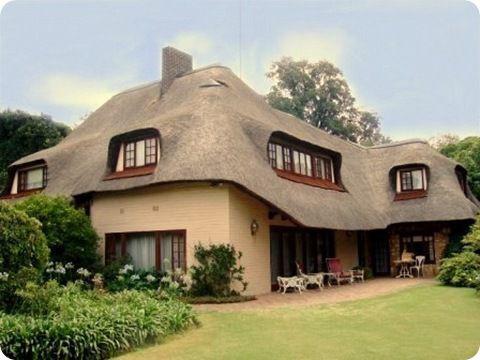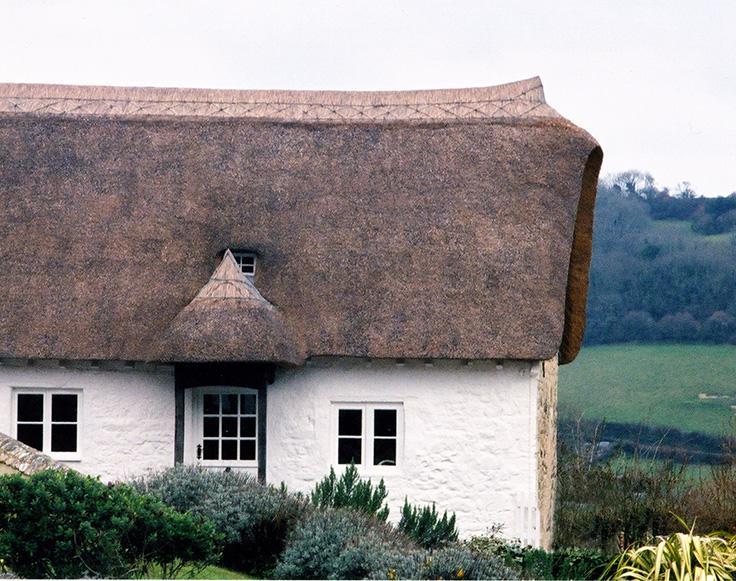The first image is the image on the left, the second image is the image on the right. For the images displayed, is the sentence "The roof in the left image is straight across the bottom and forms a simple triangle shape." factually correct? Answer yes or no. No. 